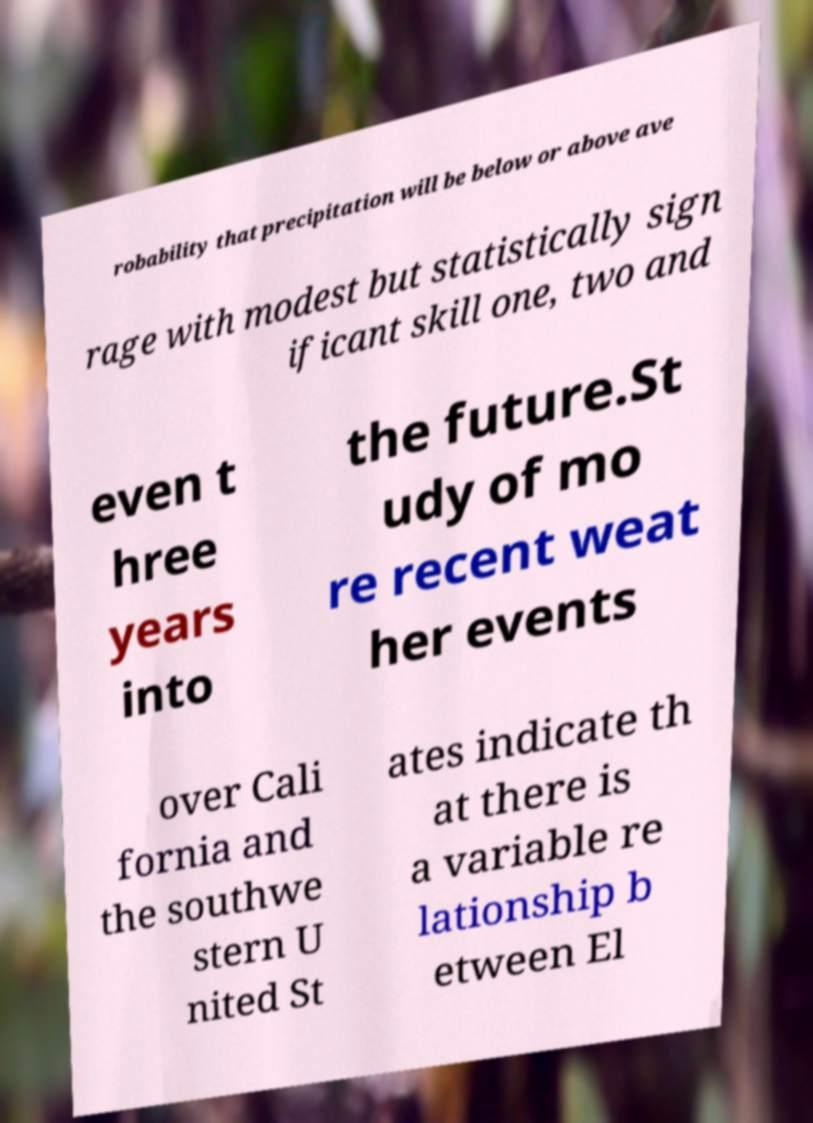There's text embedded in this image that I need extracted. Can you transcribe it verbatim? robability that precipitation will be below or above ave rage with modest but statistically sign ificant skill one, two and even t hree years into the future.St udy of mo re recent weat her events over Cali fornia and the southwe stern U nited St ates indicate th at there is a variable re lationship b etween El 